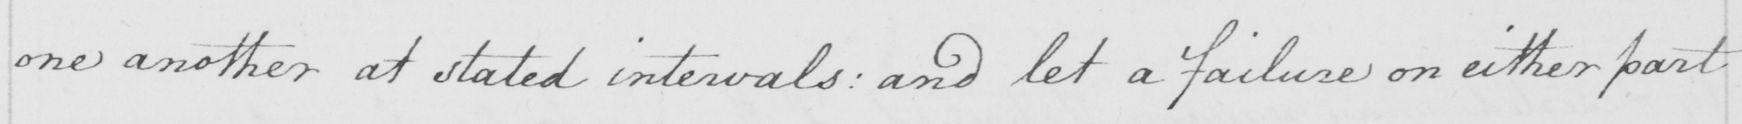Please transcribe the handwritten text in this image. one another at stated intervals: and let a failure on either part 